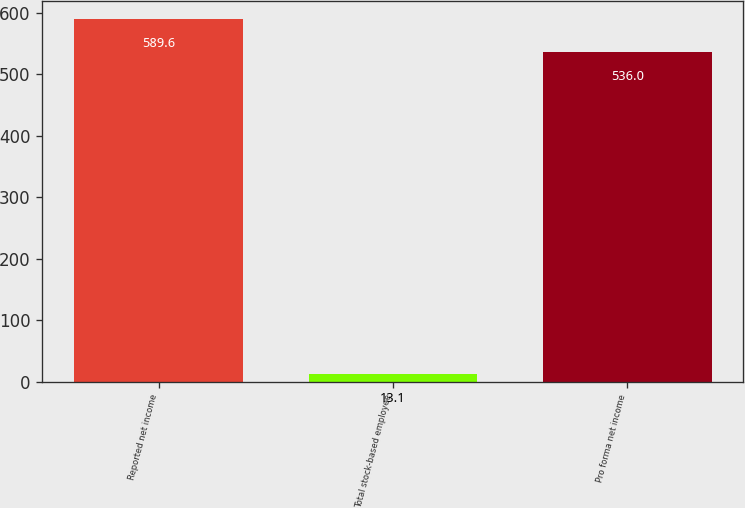<chart> <loc_0><loc_0><loc_500><loc_500><bar_chart><fcel>Reported net income<fcel>Total stock-based employee<fcel>Pro forma net income<nl><fcel>589.6<fcel>13.1<fcel>536<nl></chart> 